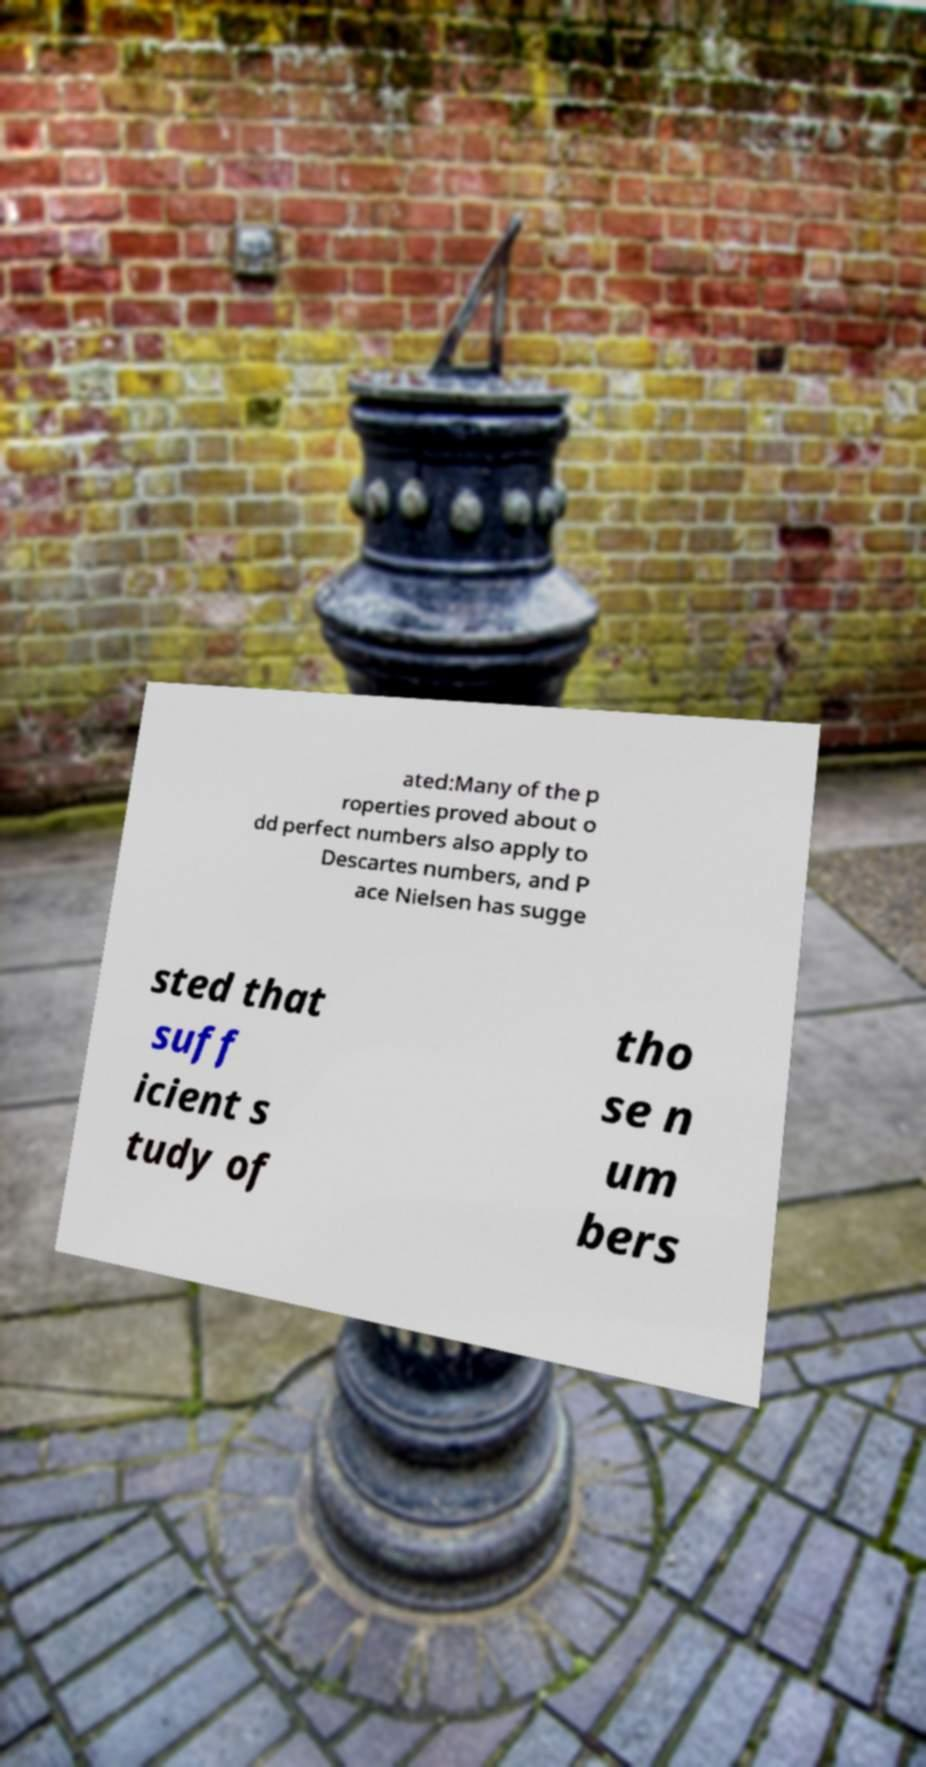For documentation purposes, I need the text within this image transcribed. Could you provide that? ated:Many of the p roperties proved about o dd perfect numbers also apply to Descartes numbers, and P ace Nielsen has sugge sted that suff icient s tudy of tho se n um bers 